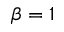Convert formula to latex. <formula><loc_0><loc_0><loc_500><loc_500>\beta = 1</formula> 